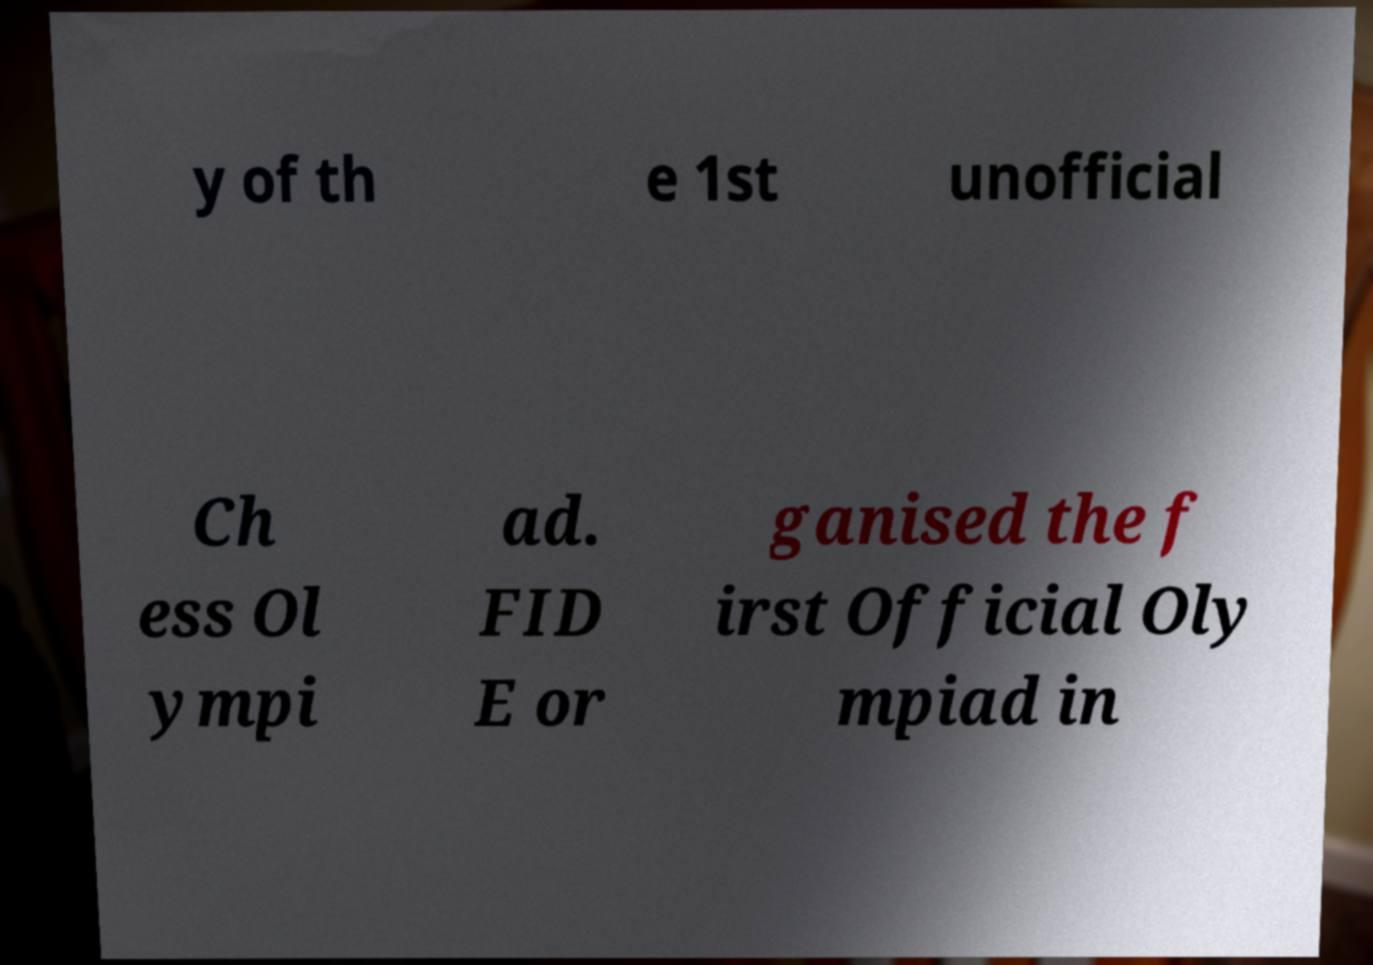I need the written content from this picture converted into text. Can you do that? y of th e 1st unofficial Ch ess Ol ympi ad. FID E or ganised the f irst Official Oly mpiad in 